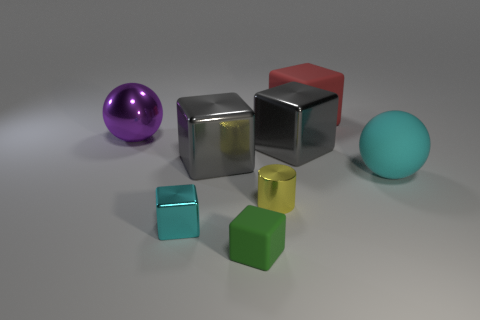Subtract all gray cylinders. How many gray cubes are left? 2 Subtract all green cubes. How many cubes are left? 4 Add 1 yellow cubes. How many objects exist? 9 Subtract 2 blocks. How many blocks are left? 3 Subtract all red blocks. How many blocks are left? 4 Subtract all yellow cubes. Subtract all blue cylinders. How many cubes are left? 5 Subtract 0 blue cylinders. How many objects are left? 8 Subtract all balls. How many objects are left? 6 Subtract all gray objects. Subtract all tiny yellow cylinders. How many objects are left? 5 Add 3 gray metal cubes. How many gray metal cubes are left? 5 